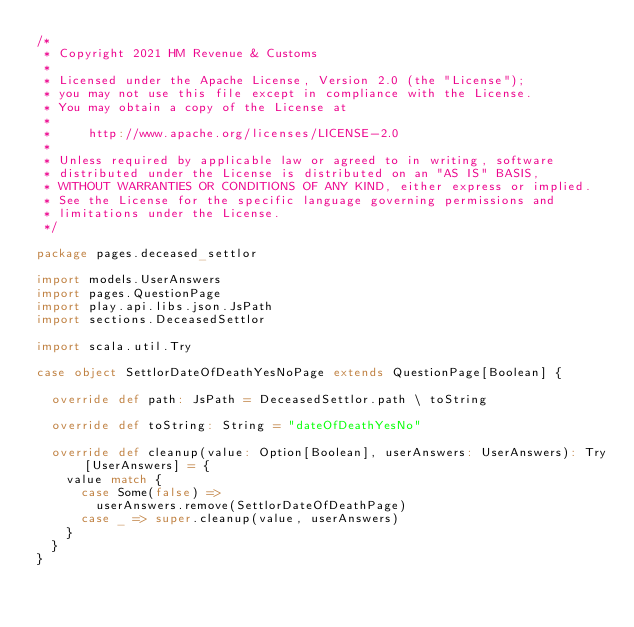Convert code to text. <code><loc_0><loc_0><loc_500><loc_500><_Scala_>/*
 * Copyright 2021 HM Revenue & Customs
 *
 * Licensed under the Apache License, Version 2.0 (the "License");
 * you may not use this file except in compliance with the License.
 * You may obtain a copy of the License at
 *
 *     http://www.apache.org/licenses/LICENSE-2.0
 *
 * Unless required by applicable law or agreed to in writing, software
 * distributed under the License is distributed on an "AS IS" BASIS,
 * WITHOUT WARRANTIES OR CONDITIONS OF ANY KIND, either express or implied.
 * See the License for the specific language governing permissions and
 * limitations under the License.
 */

package pages.deceased_settlor

import models.UserAnswers
import pages.QuestionPage
import play.api.libs.json.JsPath
import sections.DeceasedSettlor

import scala.util.Try

case object SettlorDateOfDeathYesNoPage extends QuestionPage[Boolean] {

  override def path: JsPath = DeceasedSettlor.path \ toString

  override def toString: String = "dateOfDeathYesNo"

  override def cleanup(value: Option[Boolean], userAnswers: UserAnswers): Try[UserAnswers] = {
    value match {
      case Some(false) =>
        userAnswers.remove(SettlorDateOfDeathPage)
      case _ => super.cleanup(value, userAnswers)
    }
  }
}
</code> 